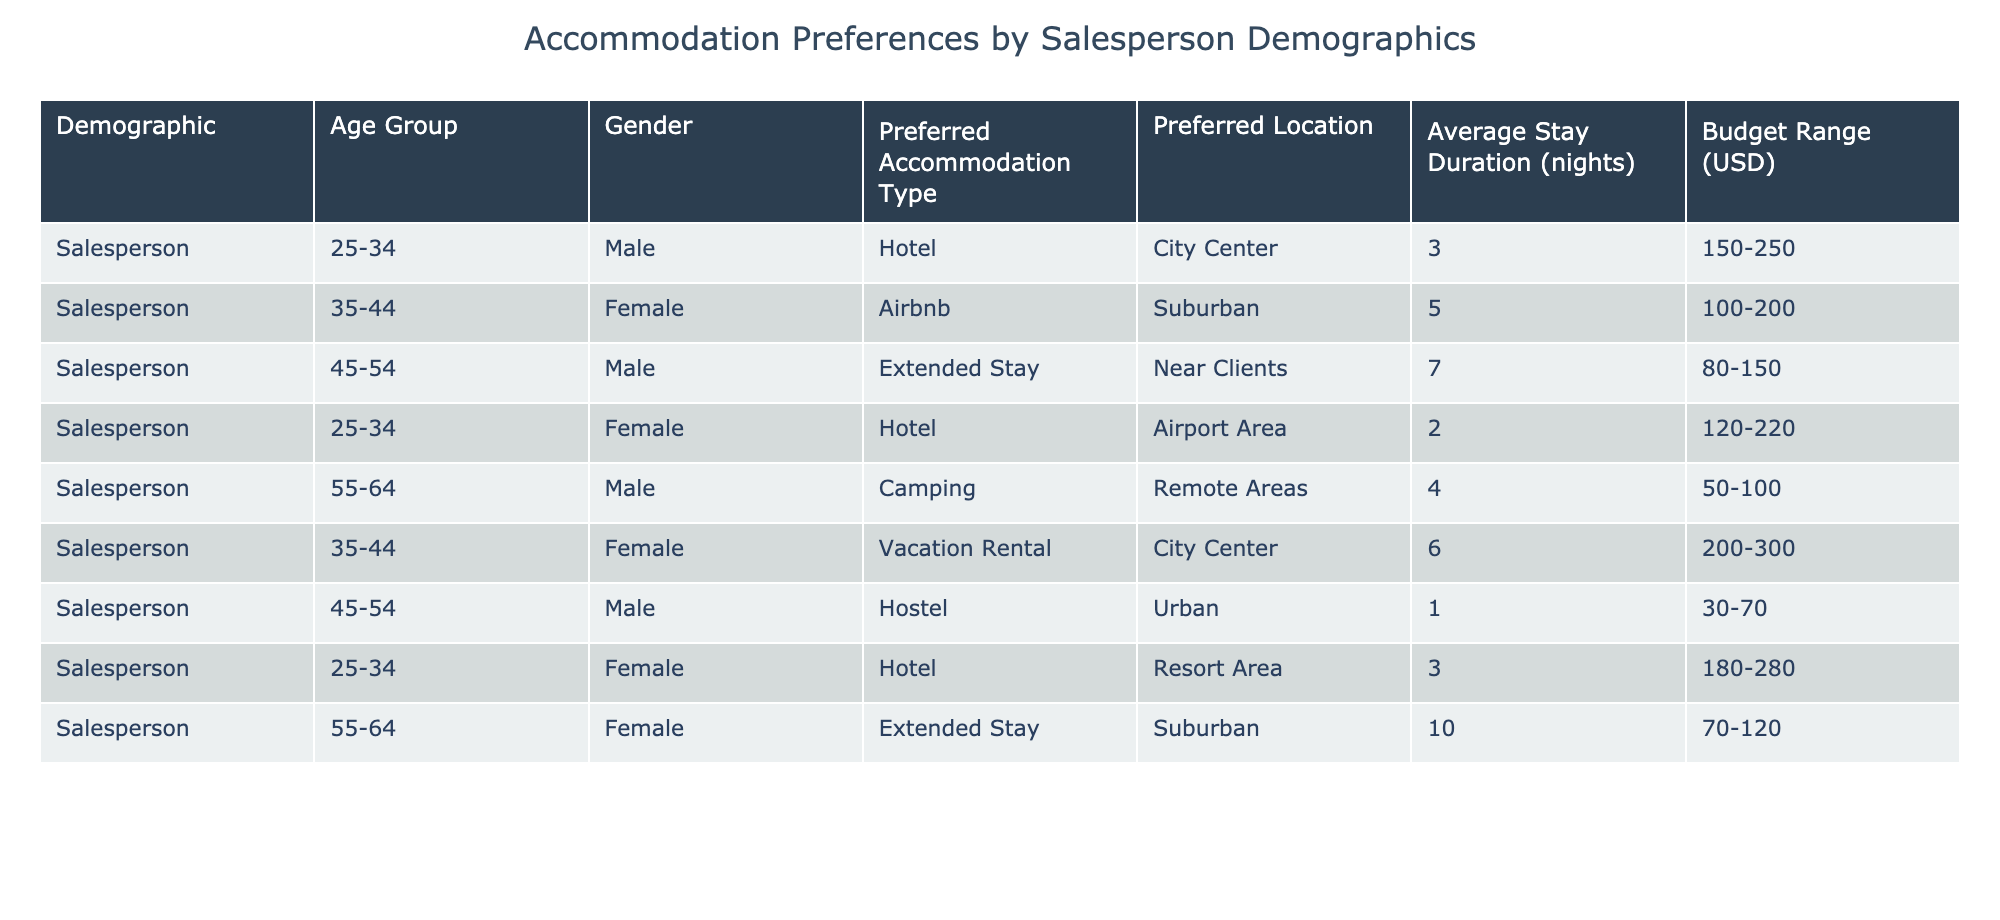What is the preferred accommodation type for salespersons aged 25-34? From the table, we can see that there are two entries for the age group 25-34: one is a Hotel and the other is also a Hotel. Therefore, the preferred accommodation type for this age group is Hotel.
Answer: Hotel How many total nights do salespersons aged 55-64 typically stay? There are two entries for the age group 55-64. One has an average stay duration of 4 nights and the other has 10 nights. So, we sum these: 4 + 10 = 14.
Answer: 14 What is the gender breakdown for salespersons who prefer Airbnb accommodations? From the table, there's only one entry for Airbnb, which is associated with a female salesperson. Therefore, the gender breakdown shows 1 female and 0 males for this preference.
Answer: 1 female, 0 males Is the average budget for salespersons preferring vacation rentals higher than for those preferring hostels? The average budget for vacation rentals (200-300) can be averaged as 250, while for hostels (30-70) it can be averaged as 50. Since 250 is greater than 50, we can conclude that the average budget for vacation rentals is higher.
Answer: Yes Which accommodation type is the least preferred by salespersons aged 45-54? Reviewing the data, the only entry for the age group 45-54 that indicates an accommodation type is Hostel, which has a stay duration of only 1 night. Since this is the only type, we can conclude it is the least preferred type within this age category.
Answer: Hostel What is the average stay duration for male salespersons compared to female salespersons? To find this, we calculate the average for males: (3 + 7 + 4 + 1) / 4 = 3.75 nights, and for females: (5 + 6 + 2 + 10) / 4 = 5.75 nights. Comparing these two averages, 5.75 is greater than 3.75.
Answer: Male: 3.75 nights, Female: 5.75 nights Are there any salespersons in the dataset that prefer camping? When looking through the table, we see one entry for camping under the 55-64 age group, listing Male as the preferred gender. Thus, there is at least one salesperson who prefers this type.
Answer: Yes What is the most budget-conscious accommodation type chosen by salespersons across all demographics? From the table, the accommodation type with the lowest average budget range is Camping (50-100), which yields an average of 75. Consequently, it is the most budget-conscious choice among all types presented.
Answer: Camping 